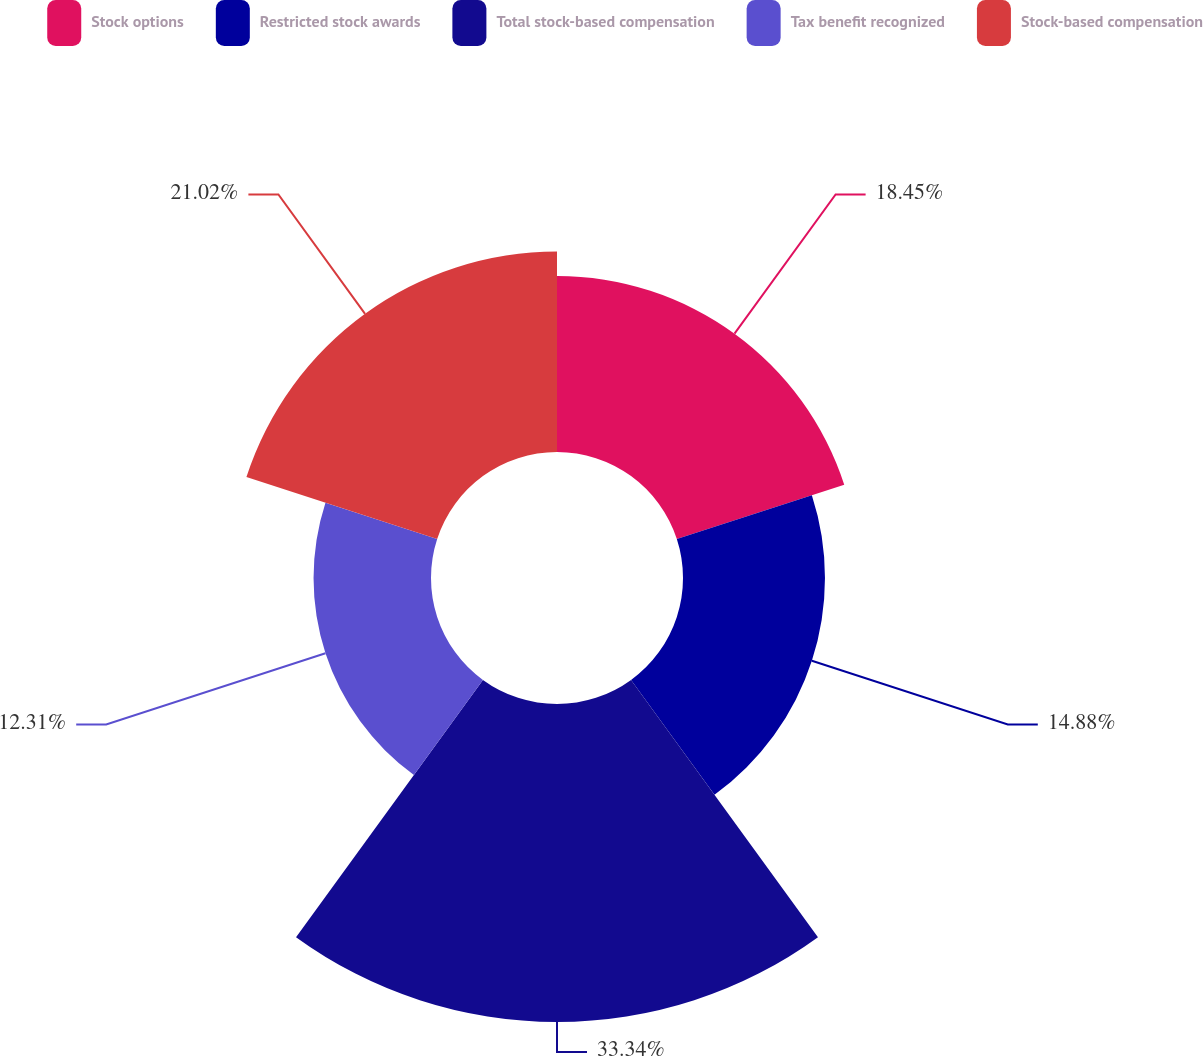Convert chart. <chart><loc_0><loc_0><loc_500><loc_500><pie_chart><fcel>Stock options<fcel>Restricted stock awards<fcel>Total stock-based compensation<fcel>Tax benefit recognized<fcel>Stock-based compensation<nl><fcel>18.45%<fcel>14.88%<fcel>33.33%<fcel>12.31%<fcel>21.02%<nl></chart> 